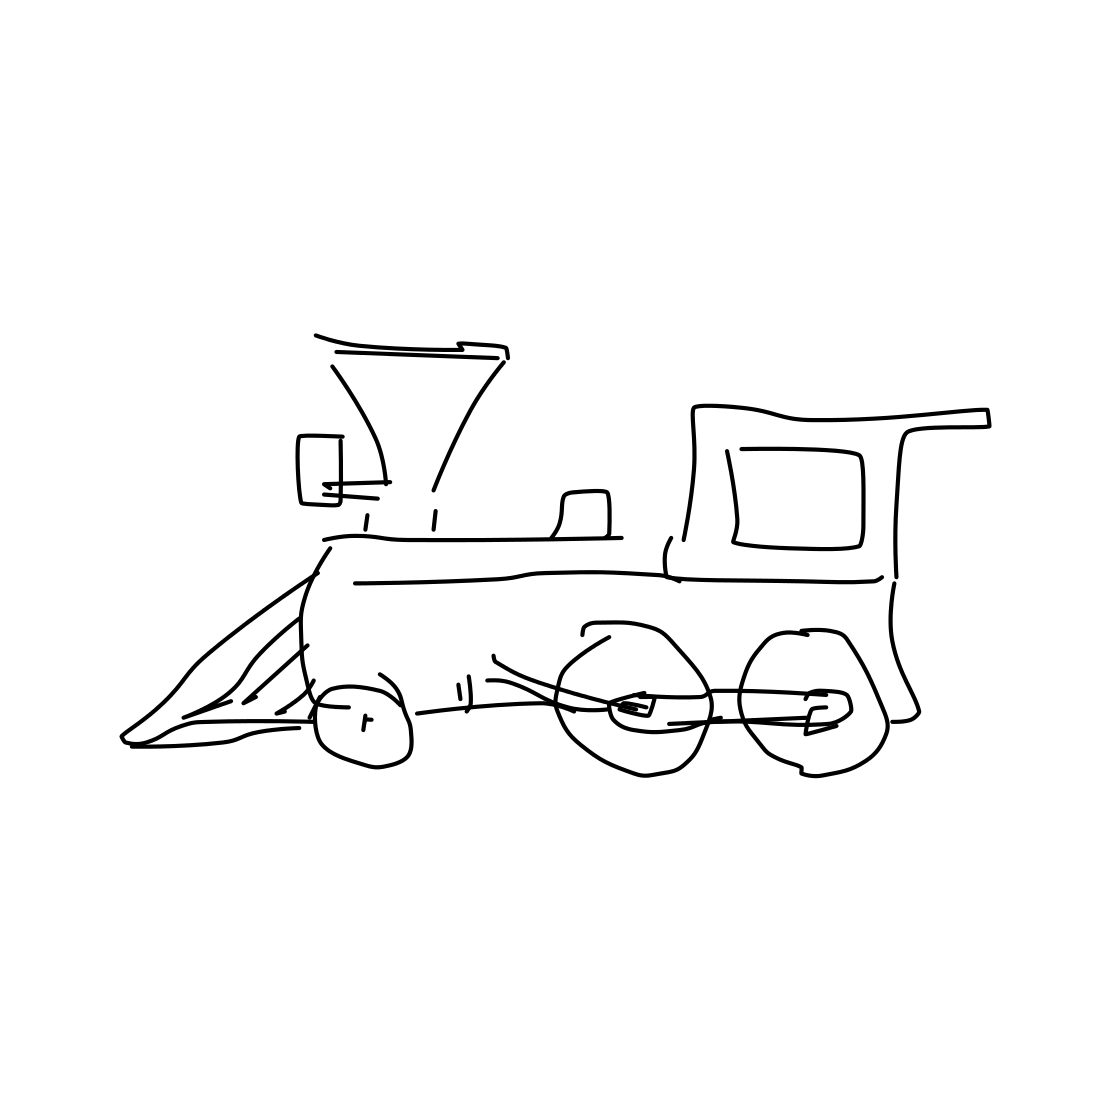Is this a train in the image? Yes 